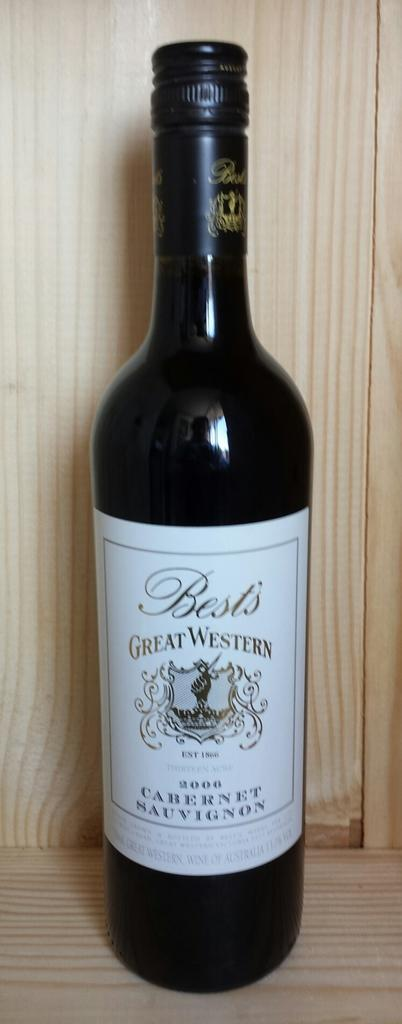Provide a one-sentence caption for the provided image. A bottle of Great Western wine with a wooden backdrop. 